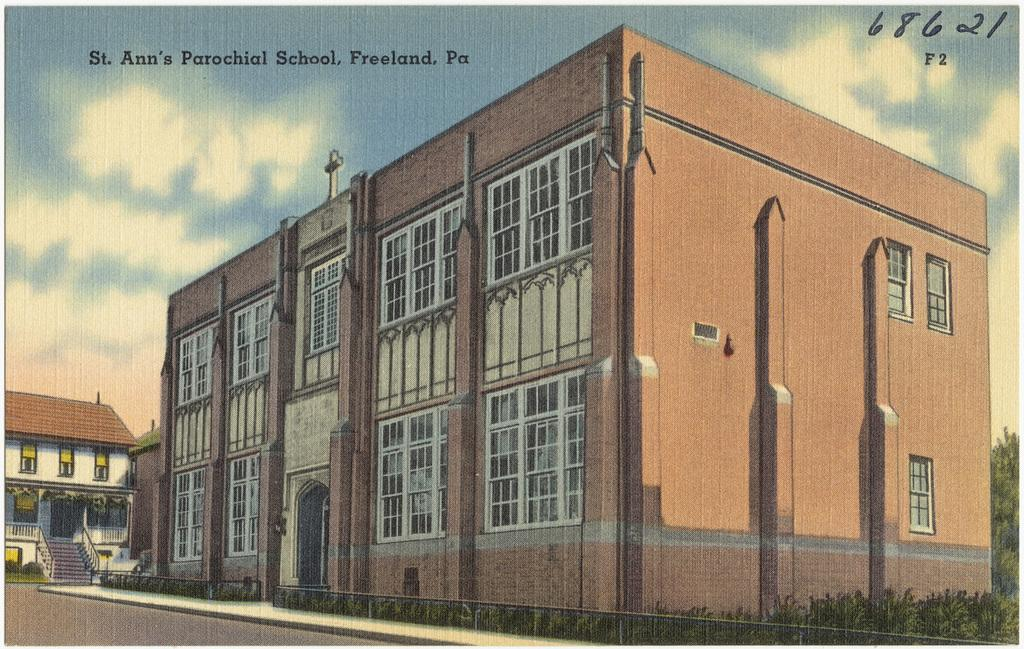What is the main subject of the poster in the image? The poster contains images of buildings, plants, stairs, a road, and the sky. What type of structures are depicted on the poster? The poster contains images of buildings. What type of natural elements are depicted on the poster? The poster contains images of plants and the sky. What type of architectural feature is depicted on the poster? The poster contains images of stairs. What type of transportation infrastructure is depicted on the poster? The poster contains images of a road. What type of sugar is used to sweeten the zephyr in the image? There is no sugar or zephyr present in the image; the poster contains images of buildings, plants, stairs, a road, and the sky. 